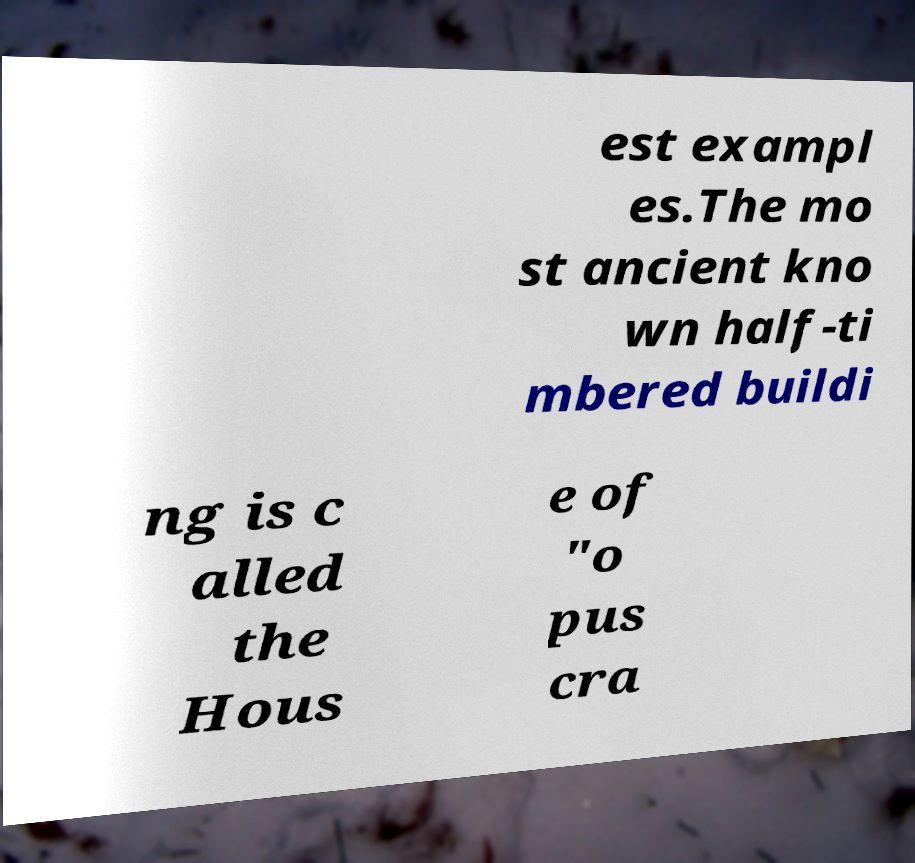There's text embedded in this image that I need extracted. Can you transcribe it verbatim? est exampl es.The mo st ancient kno wn half-ti mbered buildi ng is c alled the Hous e of "o pus cra 